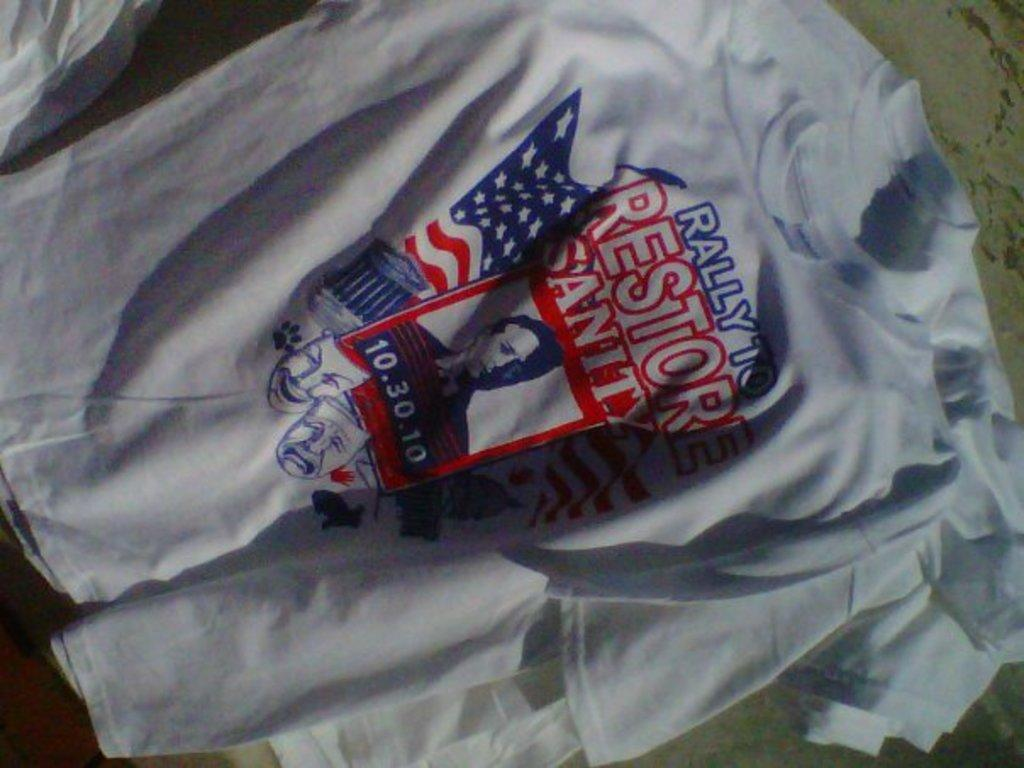<image>
Present a compact description of the photo's key features. a shirt that has the word rally on it 